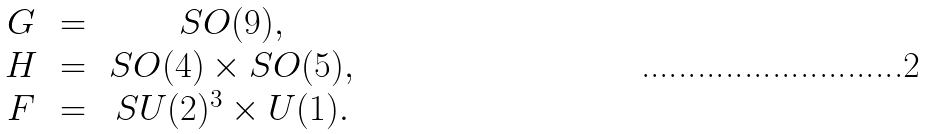<formula> <loc_0><loc_0><loc_500><loc_500>\begin{array} { c c c } G & \, = \, & S O ( 9 ) , \\ H & \, = \, & S O ( 4 ) \times S O ( 5 ) , \\ F & \, = \, & S U ( 2 ) ^ { 3 } \times U ( 1 ) . \end{array}</formula> 